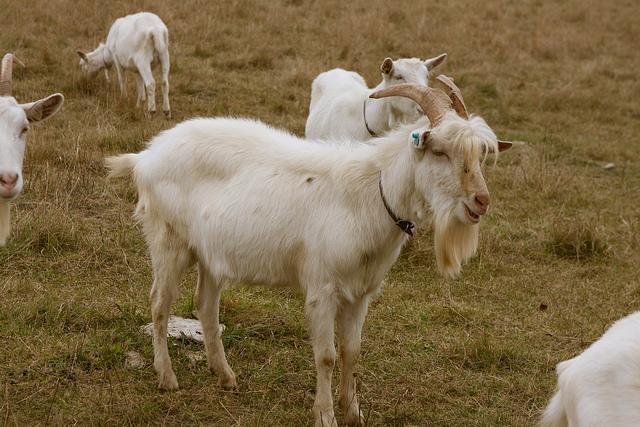How many goats are here?
Give a very brief answer. 5. How many sheep are visible?
Give a very brief answer. 5. How many people are surfing in the water?
Give a very brief answer. 0. 